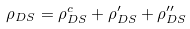<formula> <loc_0><loc_0><loc_500><loc_500>\rho _ { D S } = \rho _ { D S } ^ { c } + \rho _ { D S } ^ { \prime } + \rho _ { D S } ^ { \prime \prime }</formula> 